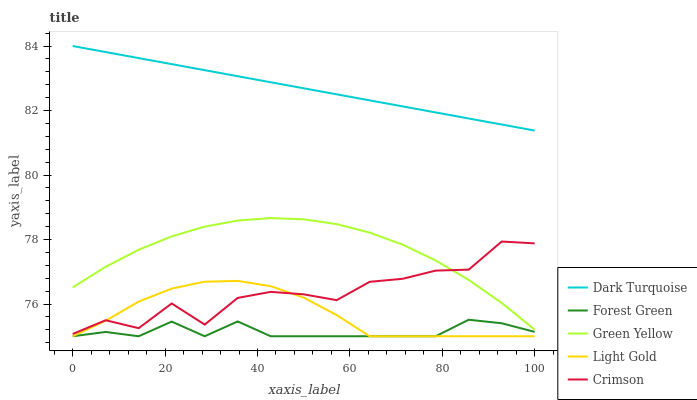Does Dark Turquoise have the minimum area under the curve?
Answer yes or no. No. Does Forest Green have the maximum area under the curve?
Answer yes or no. No. Is Forest Green the smoothest?
Answer yes or no. No. Is Forest Green the roughest?
Answer yes or no. No. Does Dark Turquoise have the lowest value?
Answer yes or no. No. Does Forest Green have the highest value?
Answer yes or no. No. Is Light Gold less than Dark Turquoise?
Answer yes or no. Yes. Is Crimson greater than Forest Green?
Answer yes or no. Yes. Does Light Gold intersect Dark Turquoise?
Answer yes or no. No. 